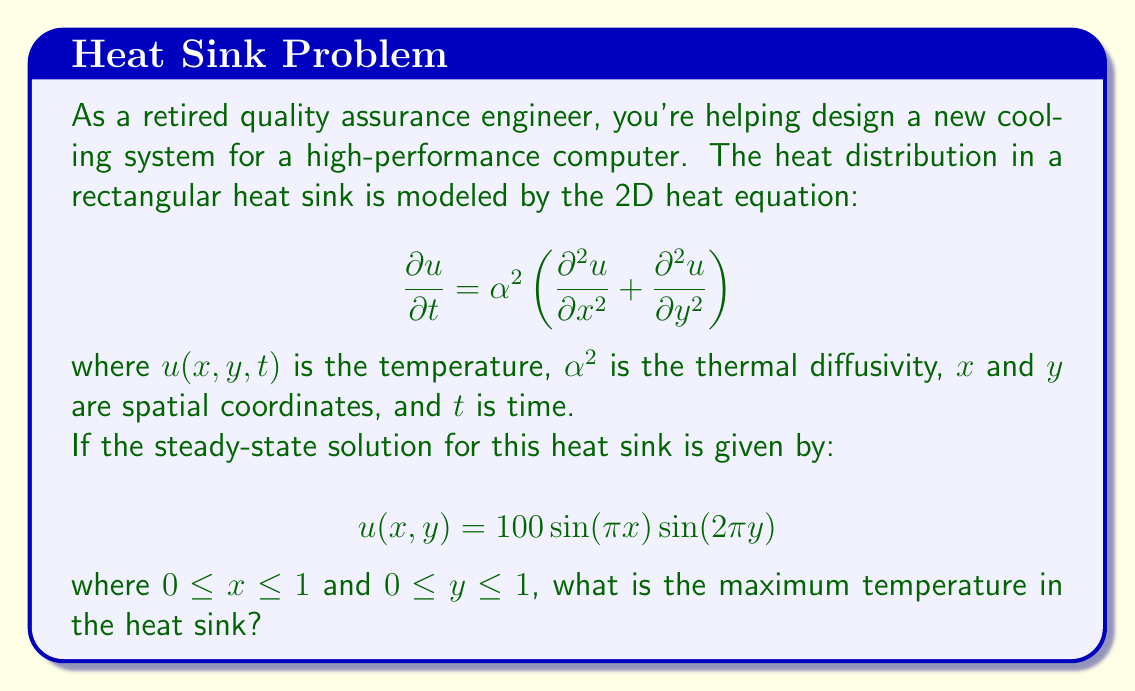Give your solution to this math problem. To find the maximum temperature in the heat sink, we need to analyze the given steady-state solution:

$$u(x,y) = 100 \sin(\pi x) \sin(2\pi y)$$

Step 1: Identify the domain
The domain is given as $0 \leq x \leq 1$ and $0 \leq y \leq 1$.

Step 2: Analyze the sinusoidal functions
- $\sin(\pi x)$ has a period of 2 and reaches its maximum value of 1 when $x = 0.5$.
- $\sin(2\pi y)$ has a period of 1 and reaches its maximum value of 1 when $y = 0.25$ or $y = 0.75$.

Step 3: Determine the maximum value
The maximum temperature will occur when both sinusoidal functions reach their maximum values simultaneously. This happens when:

$x = 0.5$ and $y = 0.25$ (or $y = 0.75$)

At these points:
$$u_{max} = 100 \cdot \sin(\pi \cdot 0.5) \cdot \sin(2\pi \cdot 0.25)$$
$$u_{max} = 100 \cdot 1 \cdot 1 = 100$$

Therefore, the maximum temperature in the heat sink is 100 (in the units used for the temperature scale, likely degrees Celsius or Kelvin).
Answer: 100 